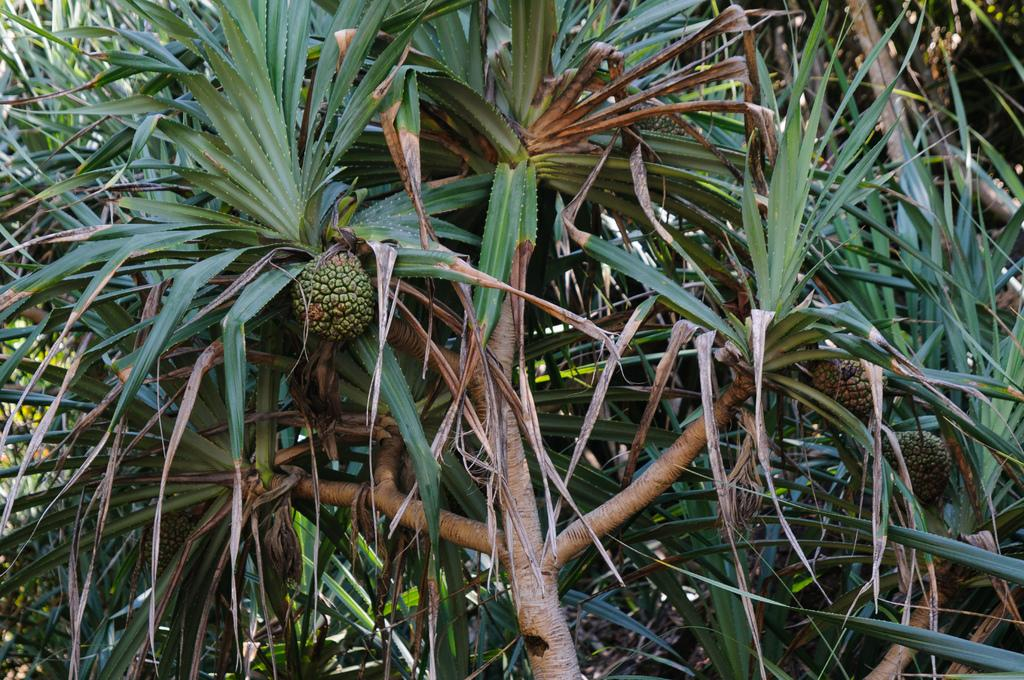What type of vegetation can be seen in the image? There are trees in the image. What is present on the trees? There are fruits on the trees. What type of marble can be seen on the ground in the image? There is no marble present in the image; it features trees with fruits. Are there any boats visible in the image? There are no boats present in the image; it features trees with fruits. 